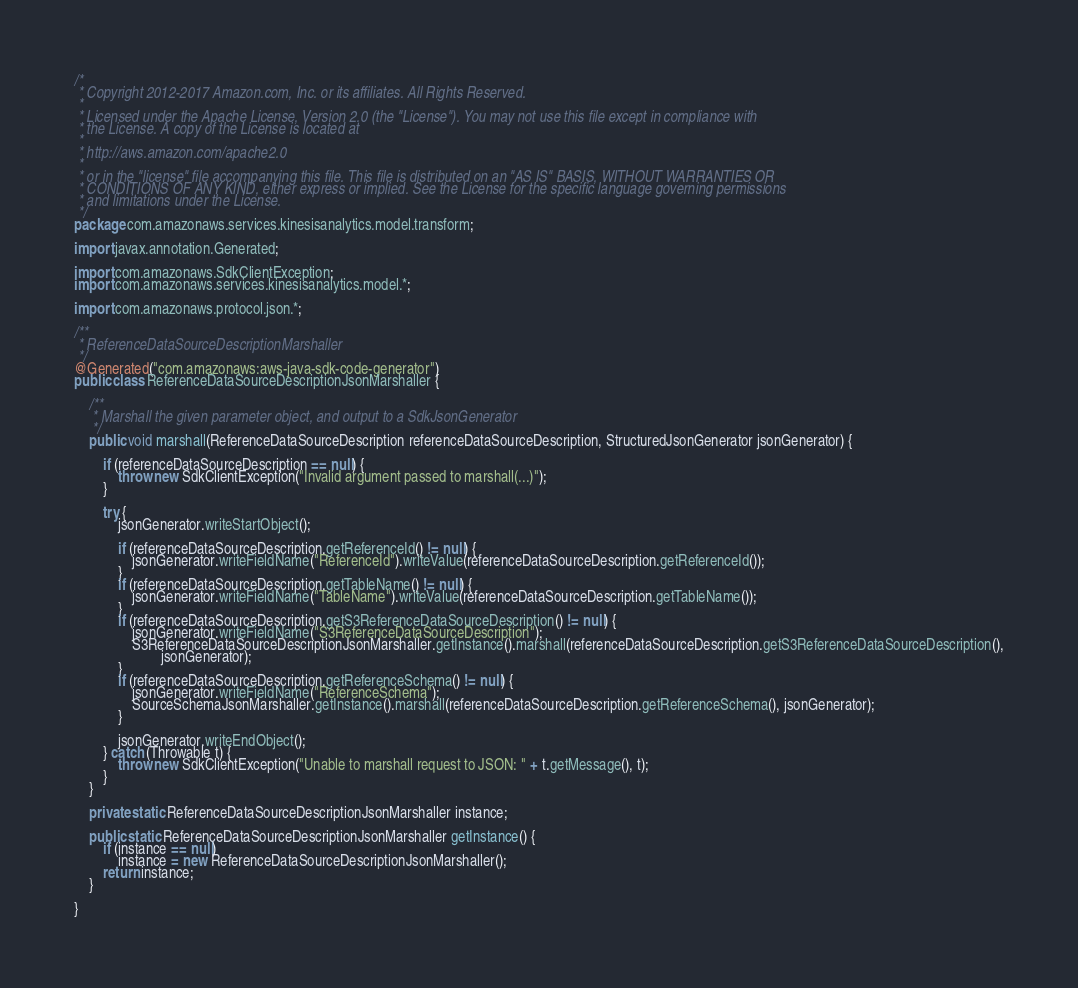Convert code to text. <code><loc_0><loc_0><loc_500><loc_500><_Java_>/*
 * Copyright 2012-2017 Amazon.com, Inc. or its affiliates. All Rights Reserved.
 * 
 * Licensed under the Apache License, Version 2.0 (the "License"). You may not use this file except in compliance with
 * the License. A copy of the License is located at
 * 
 * http://aws.amazon.com/apache2.0
 * 
 * or in the "license" file accompanying this file. This file is distributed on an "AS IS" BASIS, WITHOUT WARRANTIES OR
 * CONDITIONS OF ANY KIND, either express or implied. See the License for the specific language governing permissions
 * and limitations under the License.
 */
package com.amazonaws.services.kinesisanalytics.model.transform;

import javax.annotation.Generated;

import com.amazonaws.SdkClientException;
import com.amazonaws.services.kinesisanalytics.model.*;

import com.amazonaws.protocol.json.*;

/**
 * ReferenceDataSourceDescriptionMarshaller
 */
@Generated("com.amazonaws:aws-java-sdk-code-generator")
public class ReferenceDataSourceDescriptionJsonMarshaller {

    /**
     * Marshall the given parameter object, and output to a SdkJsonGenerator
     */
    public void marshall(ReferenceDataSourceDescription referenceDataSourceDescription, StructuredJsonGenerator jsonGenerator) {

        if (referenceDataSourceDescription == null) {
            throw new SdkClientException("Invalid argument passed to marshall(...)");
        }

        try {
            jsonGenerator.writeStartObject();

            if (referenceDataSourceDescription.getReferenceId() != null) {
                jsonGenerator.writeFieldName("ReferenceId").writeValue(referenceDataSourceDescription.getReferenceId());
            }
            if (referenceDataSourceDescription.getTableName() != null) {
                jsonGenerator.writeFieldName("TableName").writeValue(referenceDataSourceDescription.getTableName());
            }
            if (referenceDataSourceDescription.getS3ReferenceDataSourceDescription() != null) {
                jsonGenerator.writeFieldName("S3ReferenceDataSourceDescription");
                S3ReferenceDataSourceDescriptionJsonMarshaller.getInstance().marshall(referenceDataSourceDescription.getS3ReferenceDataSourceDescription(),
                        jsonGenerator);
            }
            if (referenceDataSourceDescription.getReferenceSchema() != null) {
                jsonGenerator.writeFieldName("ReferenceSchema");
                SourceSchemaJsonMarshaller.getInstance().marshall(referenceDataSourceDescription.getReferenceSchema(), jsonGenerator);
            }

            jsonGenerator.writeEndObject();
        } catch (Throwable t) {
            throw new SdkClientException("Unable to marshall request to JSON: " + t.getMessage(), t);
        }
    }

    private static ReferenceDataSourceDescriptionJsonMarshaller instance;

    public static ReferenceDataSourceDescriptionJsonMarshaller getInstance() {
        if (instance == null)
            instance = new ReferenceDataSourceDescriptionJsonMarshaller();
        return instance;
    }

}
</code> 